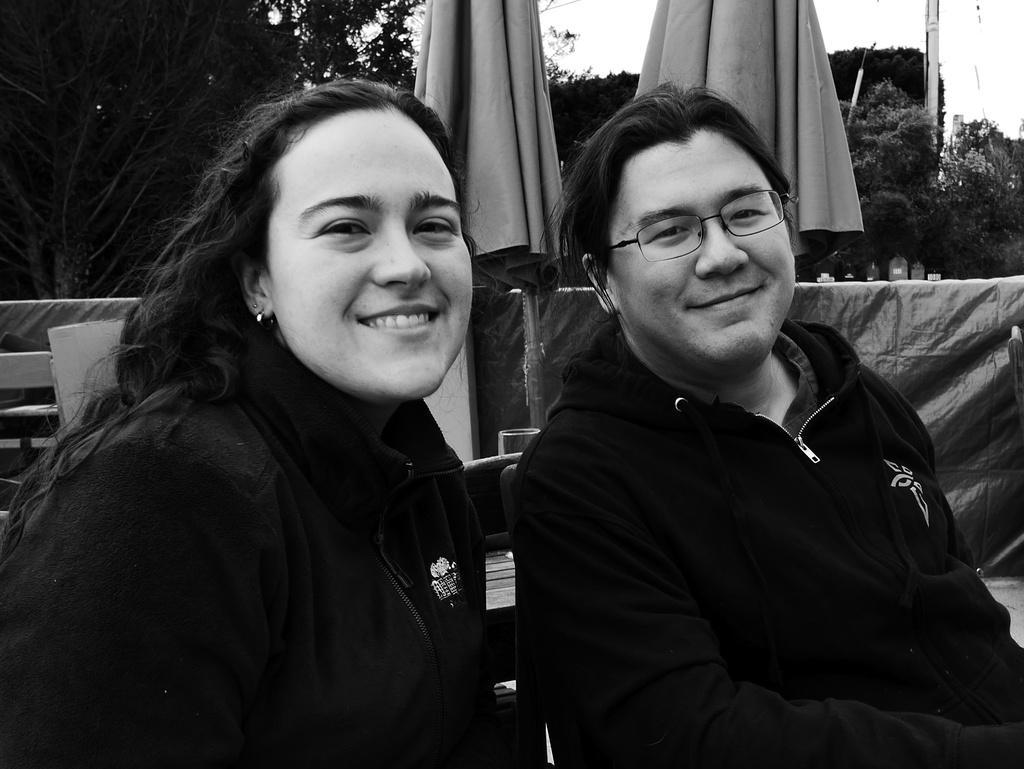How would you summarize this image in a sentence or two? In this image there are two person. There are trees on the background. There is a sky. 